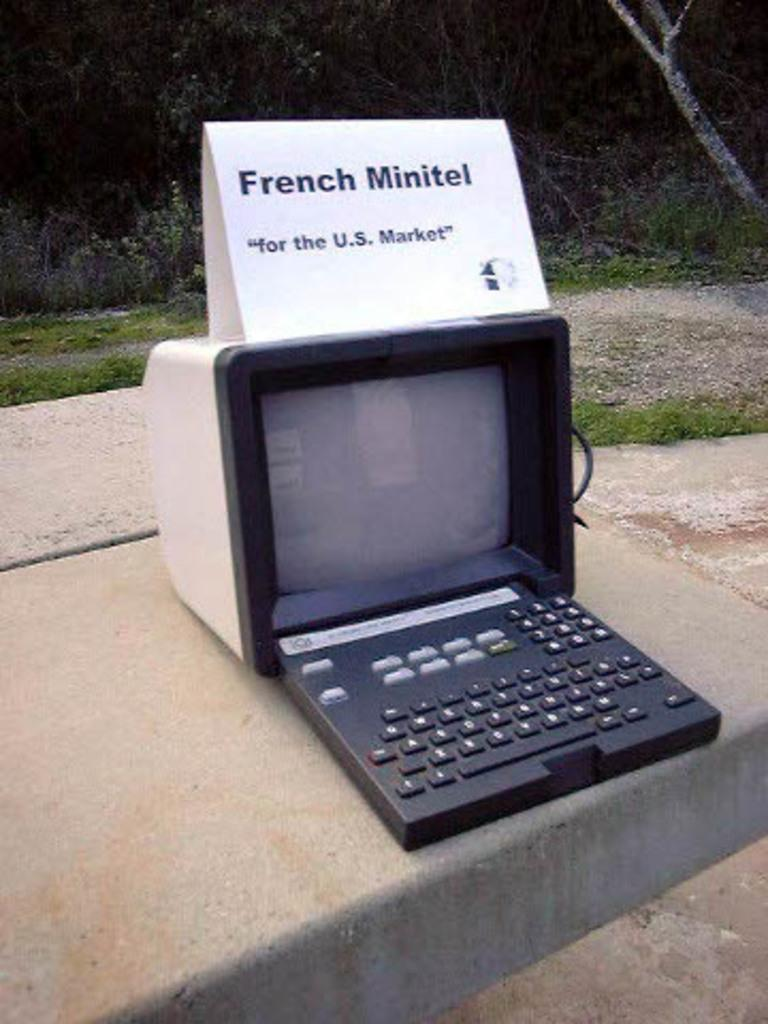<image>
Give a short and clear explanation of the subsequent image. a  sign stating for the US market sits on top of an old computer on a side walk. 